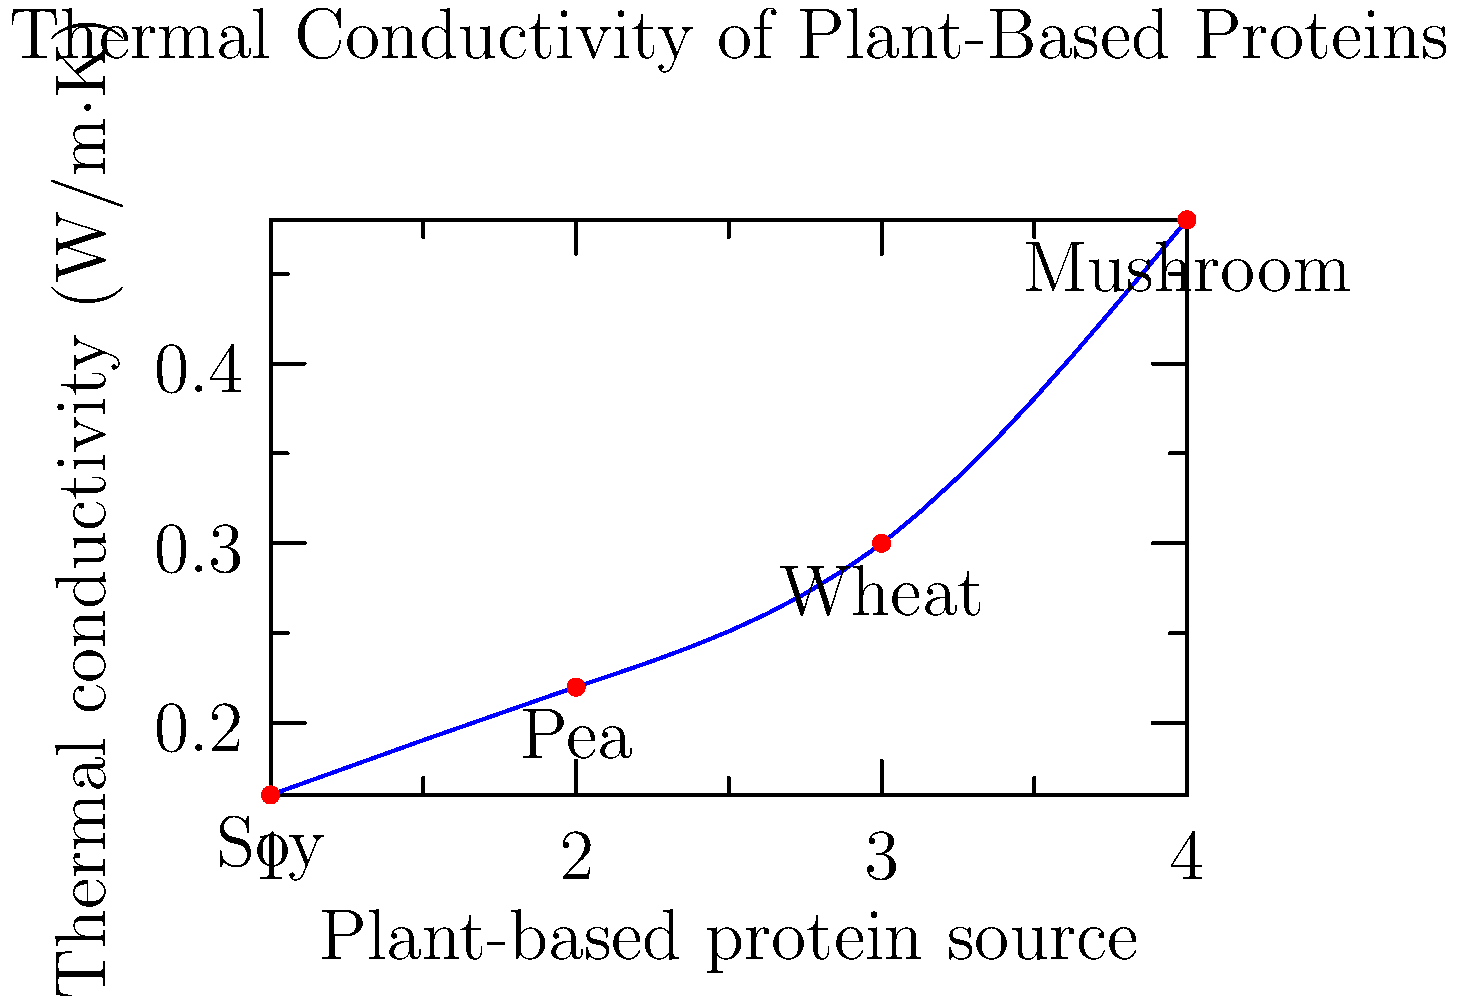As a vegan investor in plant-based companies, you're analyzing the thermal properties of various plant-based meat alternatives. The graph shows the thermal conductivity of different plant proteins used in meat substitutes. Which protein source has the highest thermal conductivity, and how much higher is it compared to the lowest one? To answer this question, we need to follow these steps:

1. Identify the highest and lowest thermal conductivity values from the graph:
   - Soy: 0.16 W/m·K
   - Pea: 0.22 W/m·K
   - Wheat: 0.30 W/m·K
   - Mushroom: 0.48 W/m·K

2. The highest thermal conductivity is for mushroom-based protein at 0.48 W/m·K.
   The lowest thermal conductivity is for soy-based protein at 0.16 W/m·K.

3. Calculate the difference:
   $\Delta \text{Thermal Conductivity} = 0.48 - 0.16 = 0.32$ W/m·K

4. Calculate the percentage increase:
   $\text{Percentage increase} = \frac{\Delta \text{Thermal Conductivity}}{\text{Lowest Thermal Conductivity}} \times 100\%$
   $= \frac{0.32}{0.16} \times 100\% = 200\%$

Therefore, mushroom-based protein has the highest thermal conductivity, and it is 200% (or 3 times) higher than the lowest one (soy-based protein).
Answer: Mushroom; 200% higher 